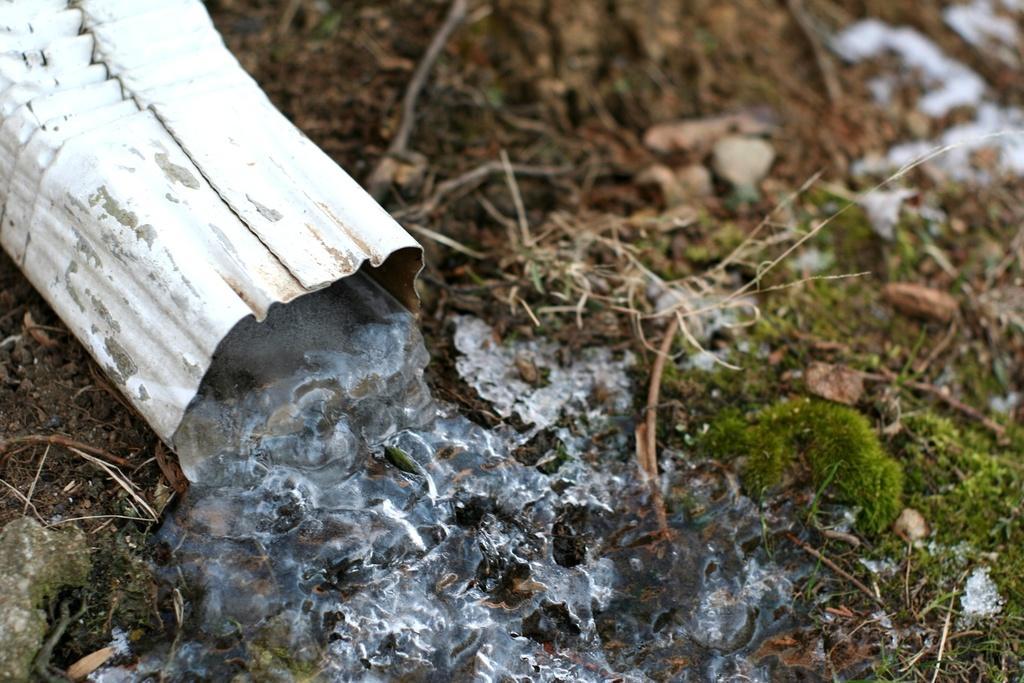Can you describe this image briefly? At the bottom of the image there is grass on the ground. At the top left of the image there is a white tube with an ice coming out of it. 